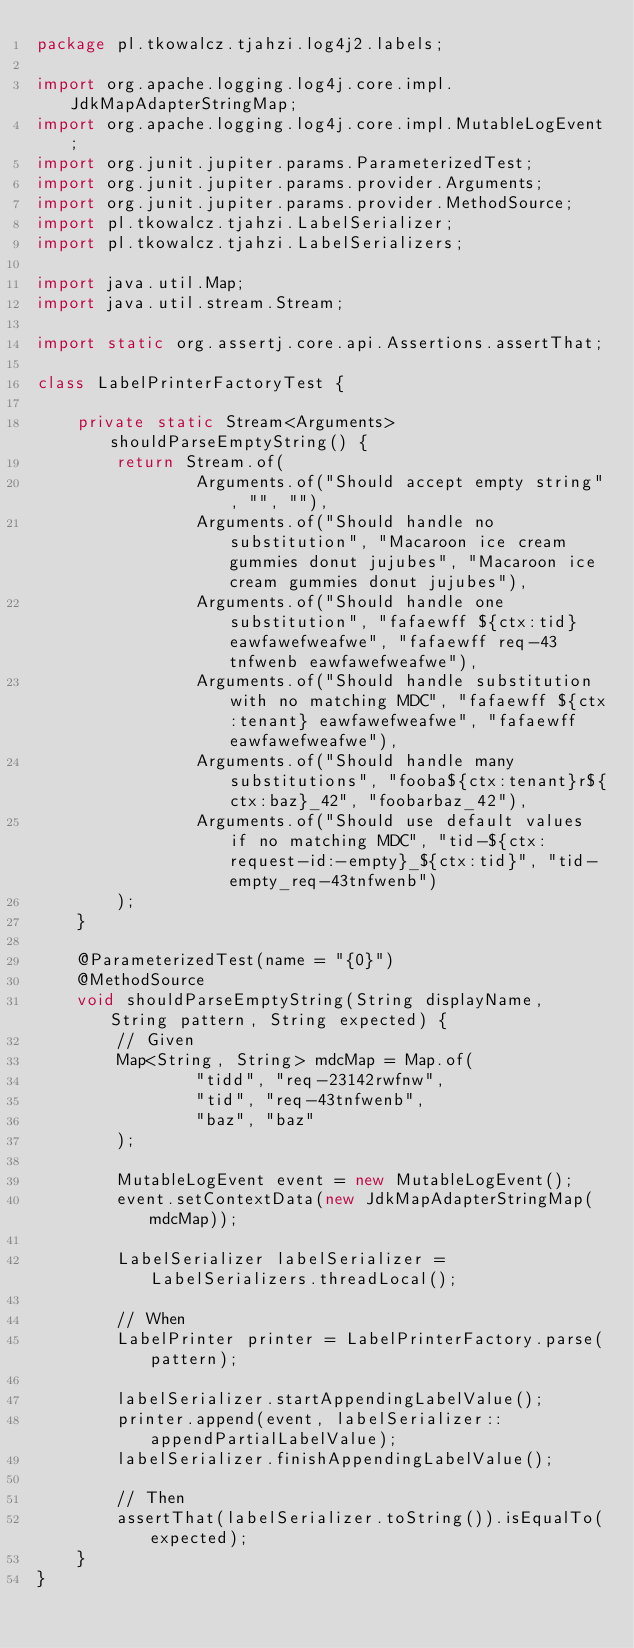<code> <loc_0><loc_0><loc_500><loc_500><_Java_>package pl.tkowalcz.tjahzi.log4j2.labels;

import org.apache.logging.log4j.core.impl.JdkMapAdapterStringMap;
import org.apache.logging.log4j.core.impl.MutableLogEvent;
import org.junit.jupiter.params.ParameterizedTest;
import org.junit.jupiter.params.provider.Arguments;
import org.junit.jupiter.params.provider.MethodSource;
import pl.tkowalcz.tjahzi.LabelSerializer;
import pl.tkowalcz.tjahzi.LabelSerializers;

import java.util.Map;
import java.util.stream.Stream;

import static org.assertj.core.api.Assertions.assertThat;

class LabelPrinterFactoryTest {

    private static Stream<Arguments> shouldParseEmptyString() {
        return Stream.of(
                Arguments.of("Should accept empty string", "", ""),
                Arguments.of("Should handle no substitution", "Macaroon ice cream gummies donut jujubes", "Macaroon ice cream gummies donut jujubes"),
                Arguments.of("Should handle one substitution", "fafaewff ${ctx:tid} eawfawefweafwe", "fafaewff req-43tnfwenb eawfawefweafwe"),
                Arguments.of("Should handle substitution with no matching MDC", "fafaewff ${ctx:tenant} eawfawefweafwe", "fafaewff  eawfawefweafwe"),
                Arguments.of("Should handle many substitutions", "fooba${ctx:tenant}r${ctx:baz}_42", "foobarbaz_42"),
                Arguments.of("Should use default values if no matching MDC", "tid-${ctx:request-id:-empty}_${ctx:tid}", "tid-empty_req-43tnfwenb")
        );
    }

    @ParameterizedTest(name = "{0}")
    @MethodSource
    void shouldParseEmptyString(String displayName, String pattern, String expected) {
        // Given
        Map<String, String> mdcMap = Map.of(
                "tidd", "req-23142rwfnw",
                "tid", "req-43tnfwenb",
                "baz", "baz"
        );

        MutableLogEvent event = new MutableLogEvent();
        event.setContextData(new JdkMapAdapterStringMap(mdcMap));

        LabelSerializer labelSerializer = LabelSerializers.threadLocal();

        // When
        LabelPrinter printer = LabelPrinterFactory.parse(pattern);

        labelSerializer.startAppendingLabelValue();
        printer.append(event, labelSerializer::appendPartialLabelValue);
        labelSerializer.finishAppendingLabelValue();

        // Then
        assertThat(labelSerializer.toString()).isEqualTo(expected);
    }
}
</code> 